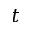Convert formula to latex. <formula><loc_0><loc_0><loc_500><loc_500>t</formula> 